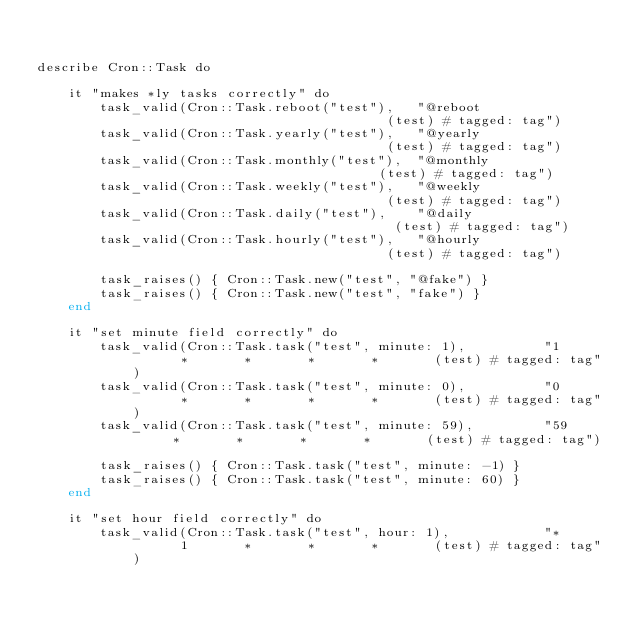<code> <loc_0><loc_0><loc_500><loc_500><_Crystal_>

describe Cron::Task do

	it "makes *ly tasks correctly" do
		task_valid(Cron::Task.reboot("test"),	"@reboot                                 (test) # tagged: tag")
		task_valid(Cron::Task.yearly("test"),	"@yearly                                 (test) # tagged: tag")
		task_valid(Cron::Task.monthly("test"),	"@monthly                                (test) # tagged: tag")
		task_valid(Cron::Task.weekly("test"),	"@weekly                                 (test) # tagged: tag")
		task_valid(Cron::Task.daily("test"),	"@daily                                  (test) # tagged: tag")
		task_valid(Cron::Task.hourly("test"),	"@hourly                                 (test) # tagged: tag")

		task_raises() { Cron::Task.new("test", "@fake") }
		task_raises() { Cron::Task.new("test", "fake") }
	end

	it "set minute field correctly" do
		task_valid(Cron::Task.task("test", minute: 1),			"1       *       *       *       *       (test) # tagged: tag")
		task_valid(Cron::Task.task("test", minute: 0),			"0       *       *       *       *       (test) # tagged: tag")
		task_valid(Cron::Task.task("test", minute: 59),			"59      *       *       *       *       (test) # tagged: tag")

		task_raises() { Cron::Task.task("test", minute: -1) }
		task_raises() { Cron::Task.task("test", minute: 60) }
	end

	it "set hour field correctly" do
		task_valid(Cron::Task.task("test", hour: 1),			"*       1       *       *       *       (test) # tagged: tag")</code> 